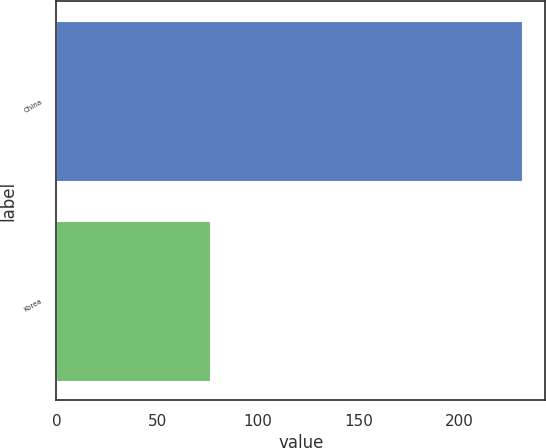Convert chart to OTSL. <chart><loc_0><loc_0><loc_500><loc_500><bar_chart><fcel>China<fcel>Korea<nl><fcel>231<fcel>76<nl></chart> 